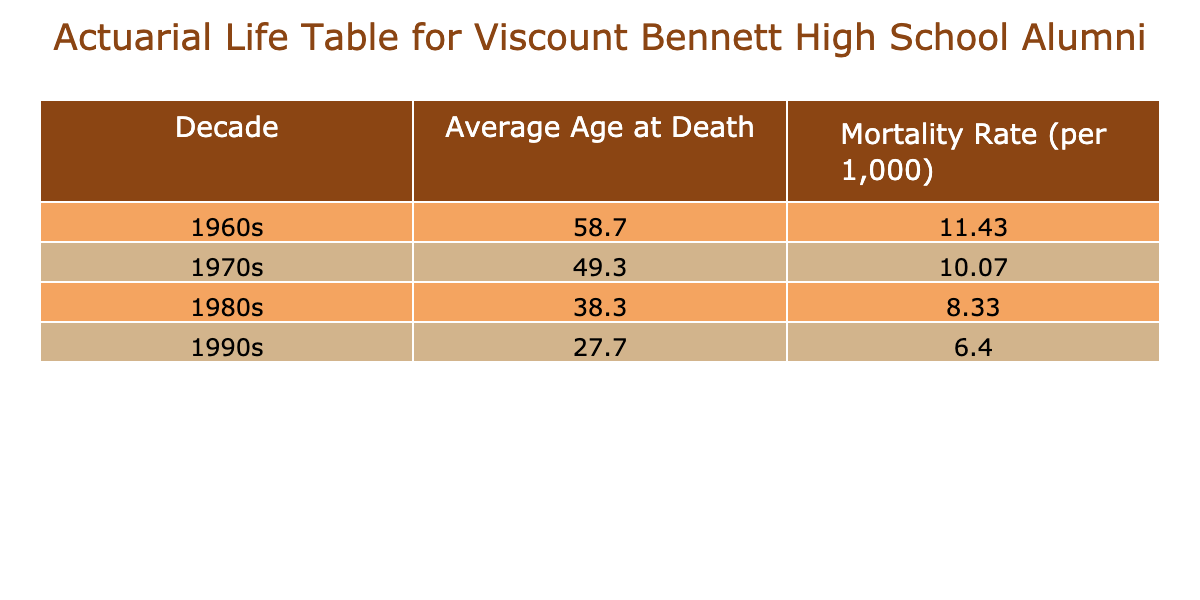What is the average age at death for alumni from the 1970s? The table shows the average age at death for each decade. Looking at the "1970s" row, we see that the average age at death is 50.0.
Answer: 50.0 Which decade has the highest average mortality rate per thousand? The table lists the average mortality rates per thousand for each decade. Comparatively, the 1960s have an average mortality rate of 11.1, which is higher than the other decades listed.
Answer: 1960s Is the average mortality rate for the 1980s lower than that for the 1990s? Checking the table, the average mortality rate for the 1980s is 8.0, while the 1990s have an average of 6.3. Since 8.0 is greater than 6.3, the statement is false.
Answer: No What is the difference between the average age at death of the 1960s and the 1990s? Looking at the table, the average age at death for the 1960s is 59.0 and for the 1990s, it is 27.7. The difference is calculated as 59.0 - 27.7 = 31.3.
Answer: 31.3 Which decade had the lowest average age at death? The average ages at death for each decade show that the 1990s have the lowest average at 27.7.
Answer: 1990s What is the total number of alumni deaths recorded for the 1970s? By checking the table, we find the recorded deaths in the 1970s: 50, 50, and 48, which adds up to 148.
Answer: 148 Was there a noticeable change in mortality rates between the 1970s and 1980s? Comparing the average mortality rates, the 1970s have an average of 10.1 while the 1980s have 8.0. This shows a decrease in mortality rates as we move from one decade to the next demonstrating a downward trend.
Answer: Yes, it decreased What is the percentage increase in average mortality rate from the 1990s to the 1960s? The average for the 1960s is 11.1, and for the 1990s it is 6.3. The difference is 11.1 - 6.3 = 4.8. To find the percentage increase: (4.8 / 6.3) * 100 = 76.2%.
Answer: 76.2% 